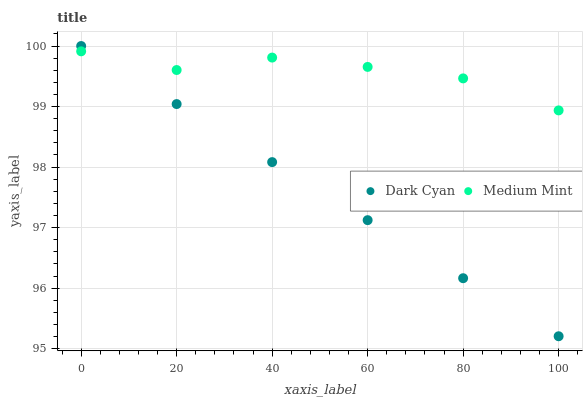Does Dark Cyan have the minimum area under the curve?
Answer yes or no. Yes. Does Medium Mint have the maximum area under the curve?
Answer yes or no. Yes. Does Medium Mint have the minimum area under the curve?
Answer yes or no. No. Is Dark Cyan the smoothest?
Answer yes or no. Yes. Is Medium Mint the roughest?
Answer yes or no. Yes. Is Medium Mint the smoothest?
Answer yes or no. No. Does Dark Cyan have the lowest value?
Answer yes or no. Yes. Does Medium Mint have the lowest value?
Answer yes or no. No. Does Dark Cyan have the highest value?
Answer yes or no. Yes. Does Medium Mint have the highest value?
Answer yes or no. No. Does Dark Cyan intersect Medium Mint?
Answer yes or no. Yes. Is Dark Cyan less than Medium Mint?
Answer yes or no. No. Is Dark Cyan greater than Medium Mint?
Answer yes or no. No. 